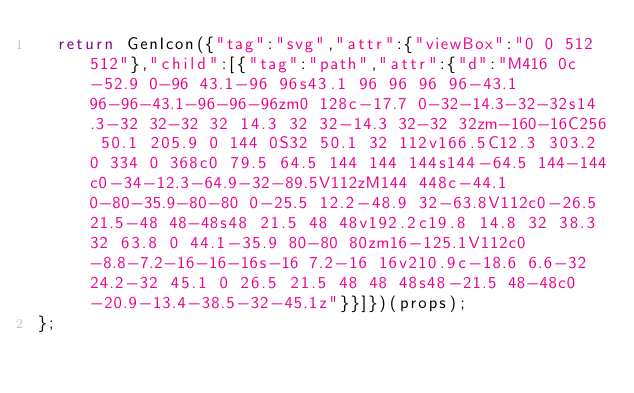<code> <loc_0><loc_0><loc_500><loc_500><_JavaScript_>  return GenIcon({"tag":"svg","attr":{"viewBox":"0 0 512 512"},"child":[{"tag":"path","attr":{"d":"M416 0c-52.9 0-96 43.1-96 96s43.1 96 96 96 96-43.1 96-96-43.1-96-96-96zm0 128c-17.7 0-32-14.3-32-32s14.3-32 32-32 32 14.3 32 32-14.3 32-32 32zm-160-16C256 50.1 205.9 0 144 0S32 50.1 32 112v166.5C12.3 303.2 0 334 0 368c0 79.5 64.5 144 144 144s144-64.5 144-144c0-34-12.3-64.9-32-89.5V112zM144 448c-44.1 0-80-35.9-80-80 0-25.5 12.2-48.9 32-63.8V112c0-26.5 21.5-48 48-48s48 21.5 48 48v192.2c19.8 14.8 32 38.3 32 63.8 0 44.1-35.9 80-80 80zm16-125.1V112c0-8.8-7.2-16-16-16s-16 7.2-16 16v210.9c-18.6 6.6-32 24.2-32 45.1 0 26.5 21.5 48 48 48s48-21.5 48-48c0-20.9-13.4-38.5-32-45.1z"}}]})(props);
};
</code> 